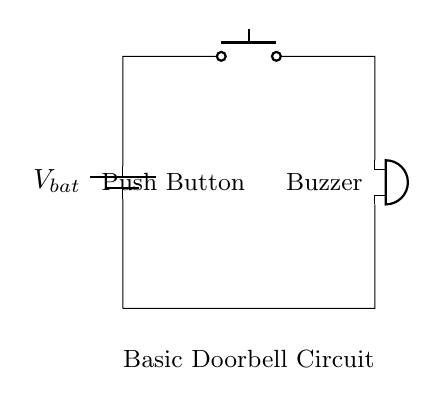What is the main component used to activate the buzzer? The main component used to activate the buzzer is the push button. When the button is pressed, it completes the circuit, allowing current to flow and energizing the buzzer.
Answer: push button What type of circuit is this? This is a simple series circuit. In a series circuit, components are connected end-to-end, and the current flows through each component one after the other.
Answer: series circuit What component is responsible for producing sound? The component responsible for producing sound is the buzzer. It converts electrical energy into sound energy when activated.
Answer: buzzer How many components are in this circuit? There are three components in this circuit: a battery, a push button, and a buzzer. Each of these plays a specific role in the functioning of the doorbell circuit.
Answer: three What would happen if the push button is not pressed? If the push button is not pressed, the circuit remains open, preventing current from flowing, and consequently, the buzzer will not sound. This is because an open circuit can’t allow any electrical flow.
Answer: buzzer does not sound What is the function of the battery in this circuit? The function of the battery in this circuit is to provide the necessary voltage to power the circuit. It serves as the source of energy that drives the current through the circuit components.
Answer: provide voltage 